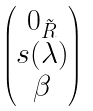<formula> <loc_0><loc_0><loc_500><loc_500>\begin{pmatrix} 0 _ { \tilde { R } } \\ s ( \lambda ) \\ \beta \end{pmatrix}</formula> 